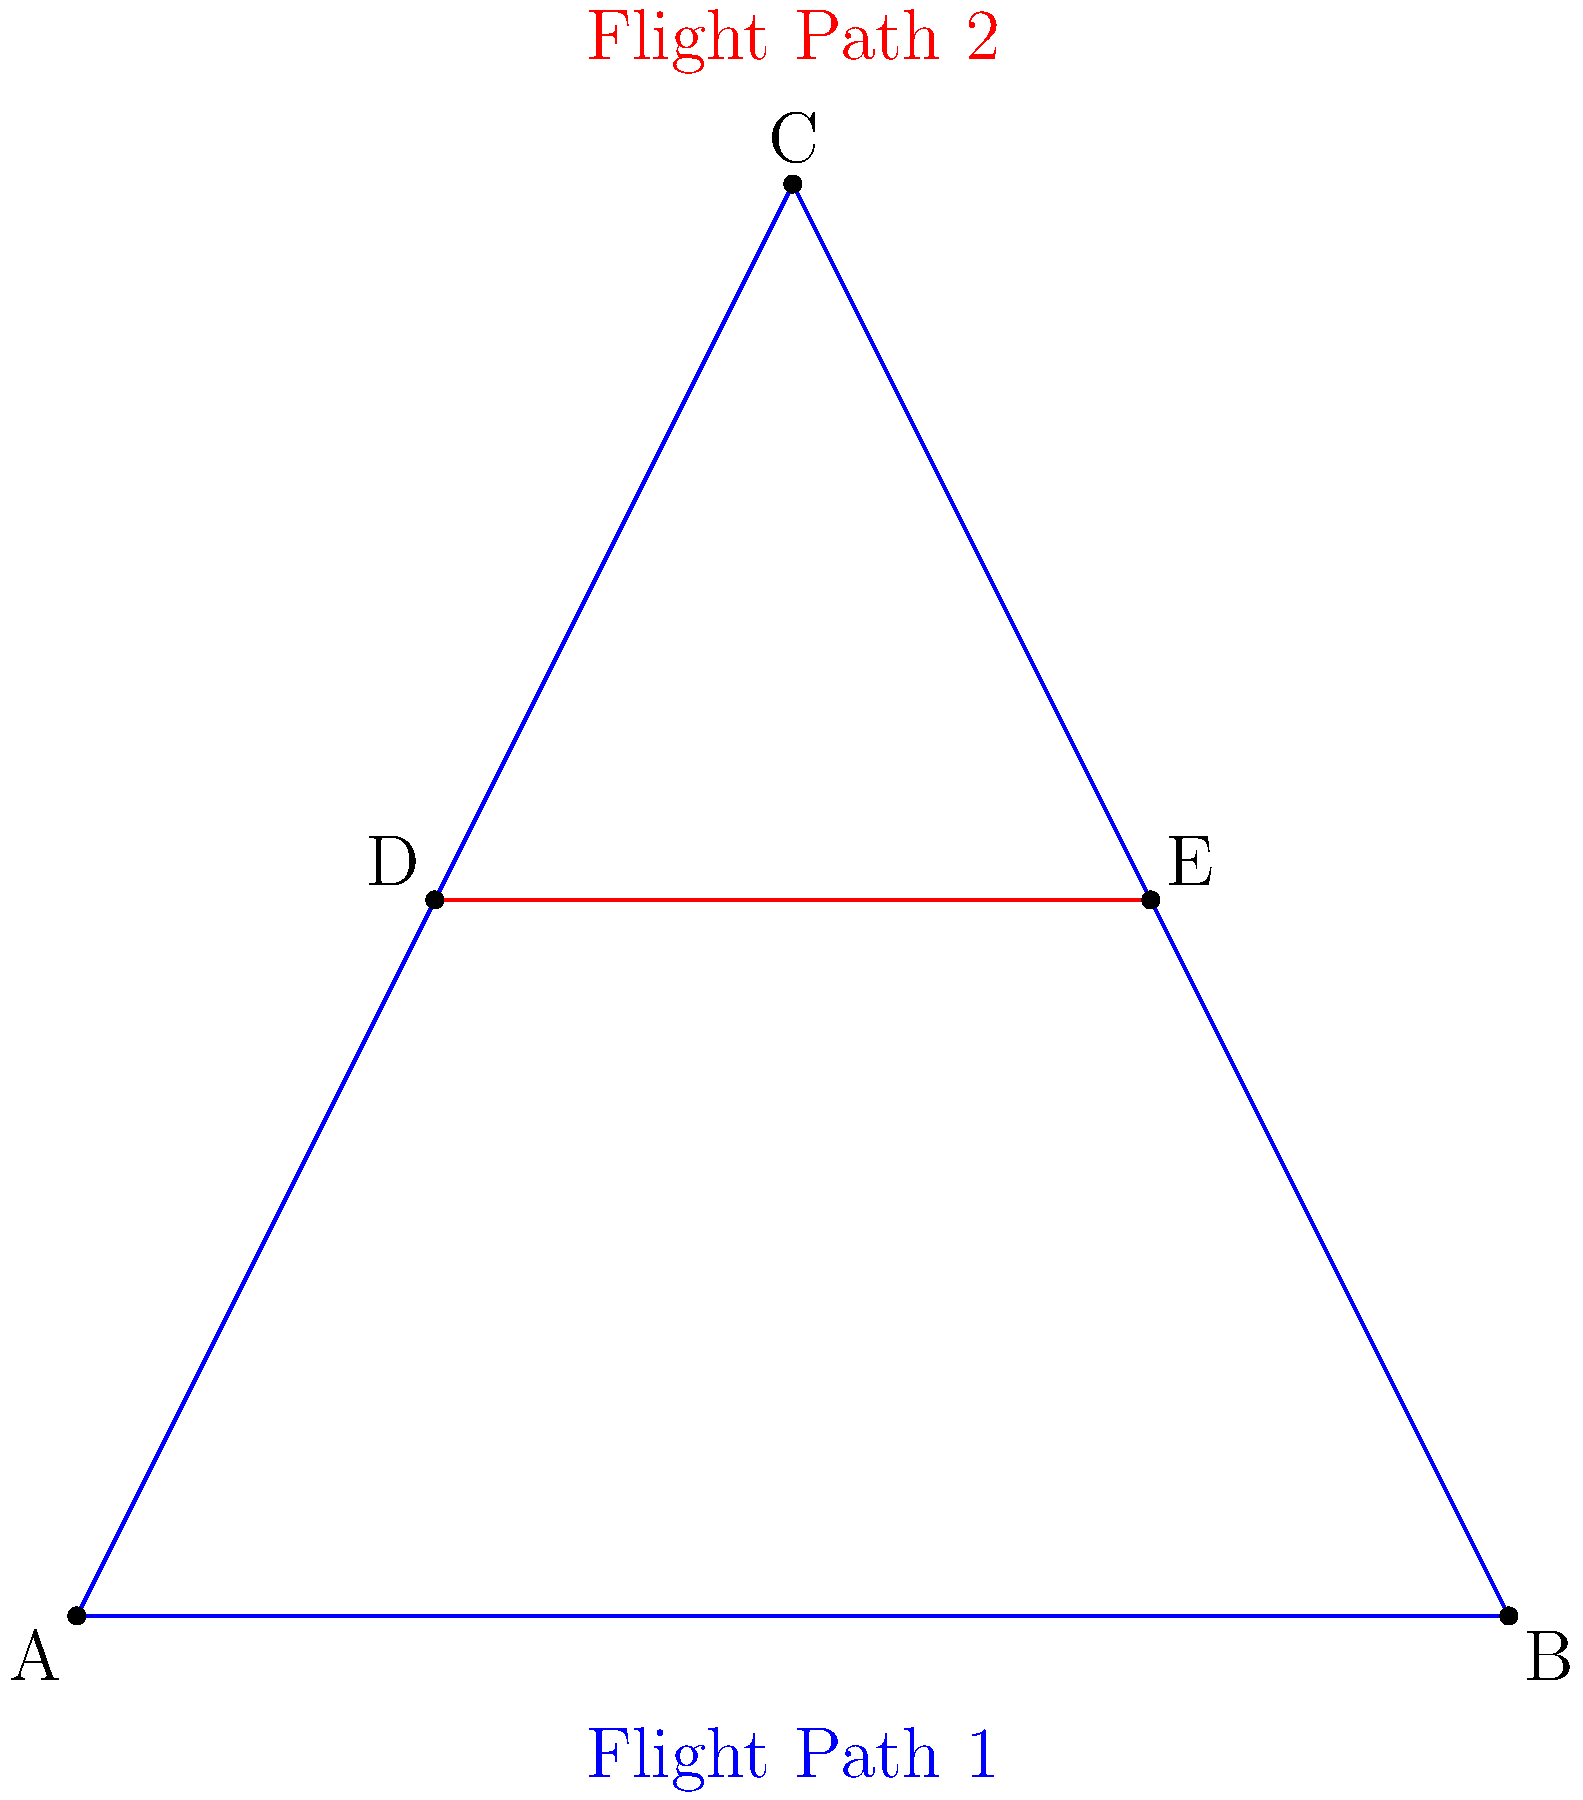In the diagram above, two flight paths are represented by triangles ABC (blue) and DE (red line segment). If the triangles are congruent, what is the length of DE in relation to the sides of triangle ABC? To solve this problem, let's follow these steps:

1. Observe that DE is a line segment within triangle ABC, connecting the midpoints of AC and BC.

2. In any triangle, a line segment connecting the midpoints of two sides is parallel to the third side and half its length. This is known as the Midpoint Theorem.

3. Therefore, DE is parallel to AB and half its length.

4. Since the triangles are congruent, all corresponding sides are equal in length.

5. The length of DE in the red flight path corresponds to half the length of AB in the blue flight path.

6. Thus, DE is equal in length to half of AB in triangle ABC.
Answer: Half of AB 